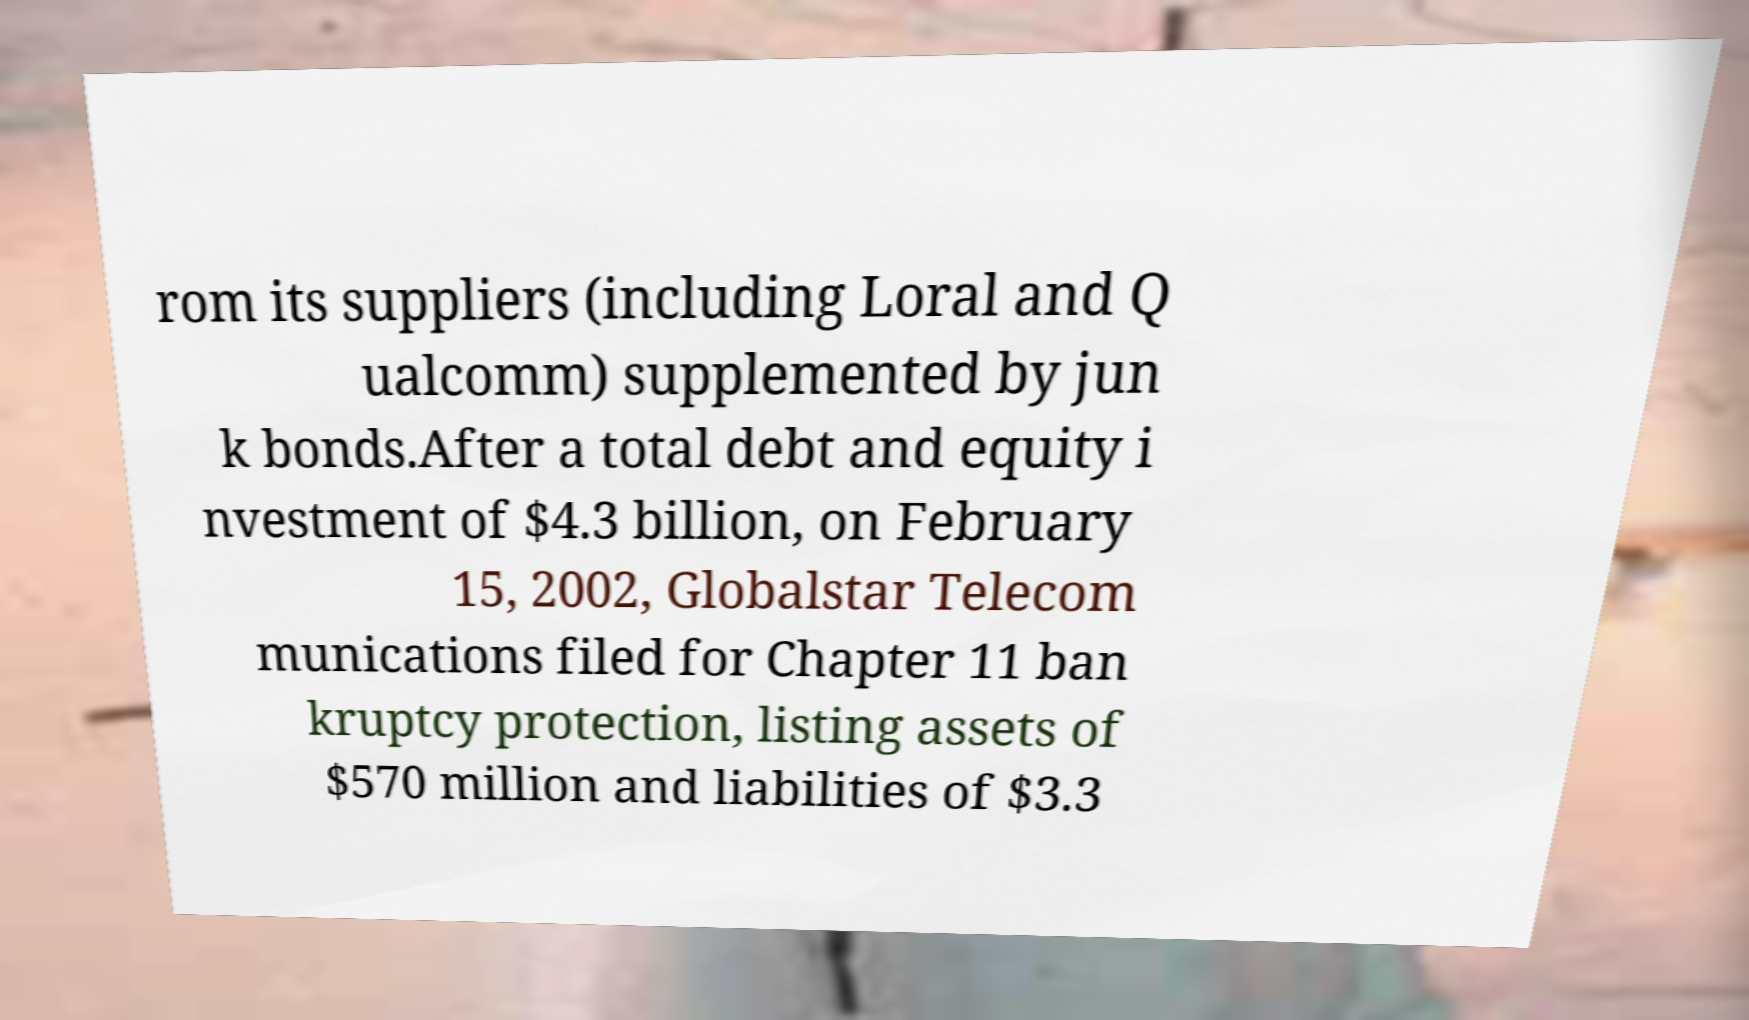There's text embedded in this image that I need extracted. Can you transcribe it verbatim? rom its suppliers (including Loral and Q ualcomm) supplemented by jun k bonds.After a total debt and equity i nvestment of $4.3 billion, on February 15, 2002, Globalstar Telecom munications filed for Chapter 11 ban kruptcy protection, listing assets of $570 million and liabilities of $3.3 